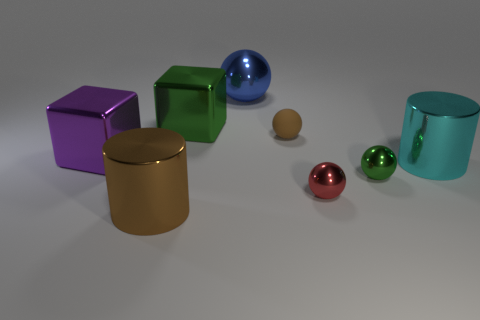Add 2 large red matte things. How many objects exist? 10 Subtract all cyan spheres. Subtract all purple cubes. How many spheres are left? 4 Subtract all blocks. How many objects are left? 6 Subtract all tiny gray balls. Subtract all cyan things. How many objects are left? 7 Add 1 purple shiny objects. How many purple shiny objects are left? 2 Add 8 cyan metal cubes. How many cyan metal cubes exist? 8 Subtract 1 brown cylinders. How many objects are left? 7 